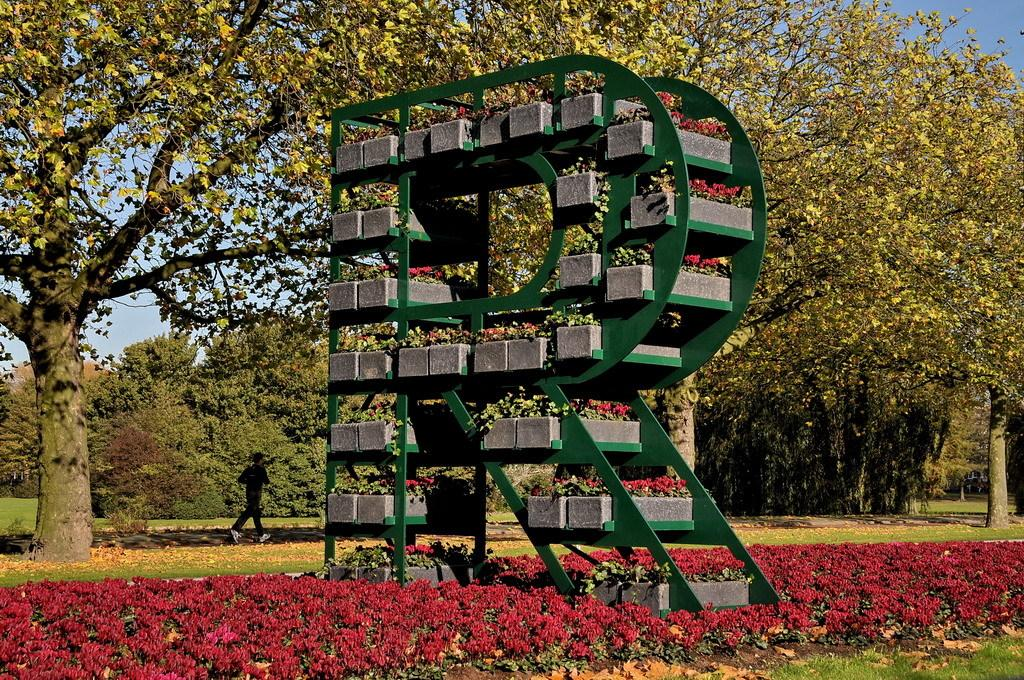What type of plants can be seen in the image? There are flowers in the image. What structure is present in the image? There is a stand in the image. What type of vegetation is visible in the background of the image? There are trees in the image. What is the person in the image doing? A person is walking on the ground in the image. What can be seen in the distance in the image? The sky is visible in the background of the image. What type of toothbrush is hanging on the curtain in the image? There is no toothbrush or curtain present in the image. What is the weather like in the image? The provided facts do not mention the weather, so we cannot determine the weather from the image. 